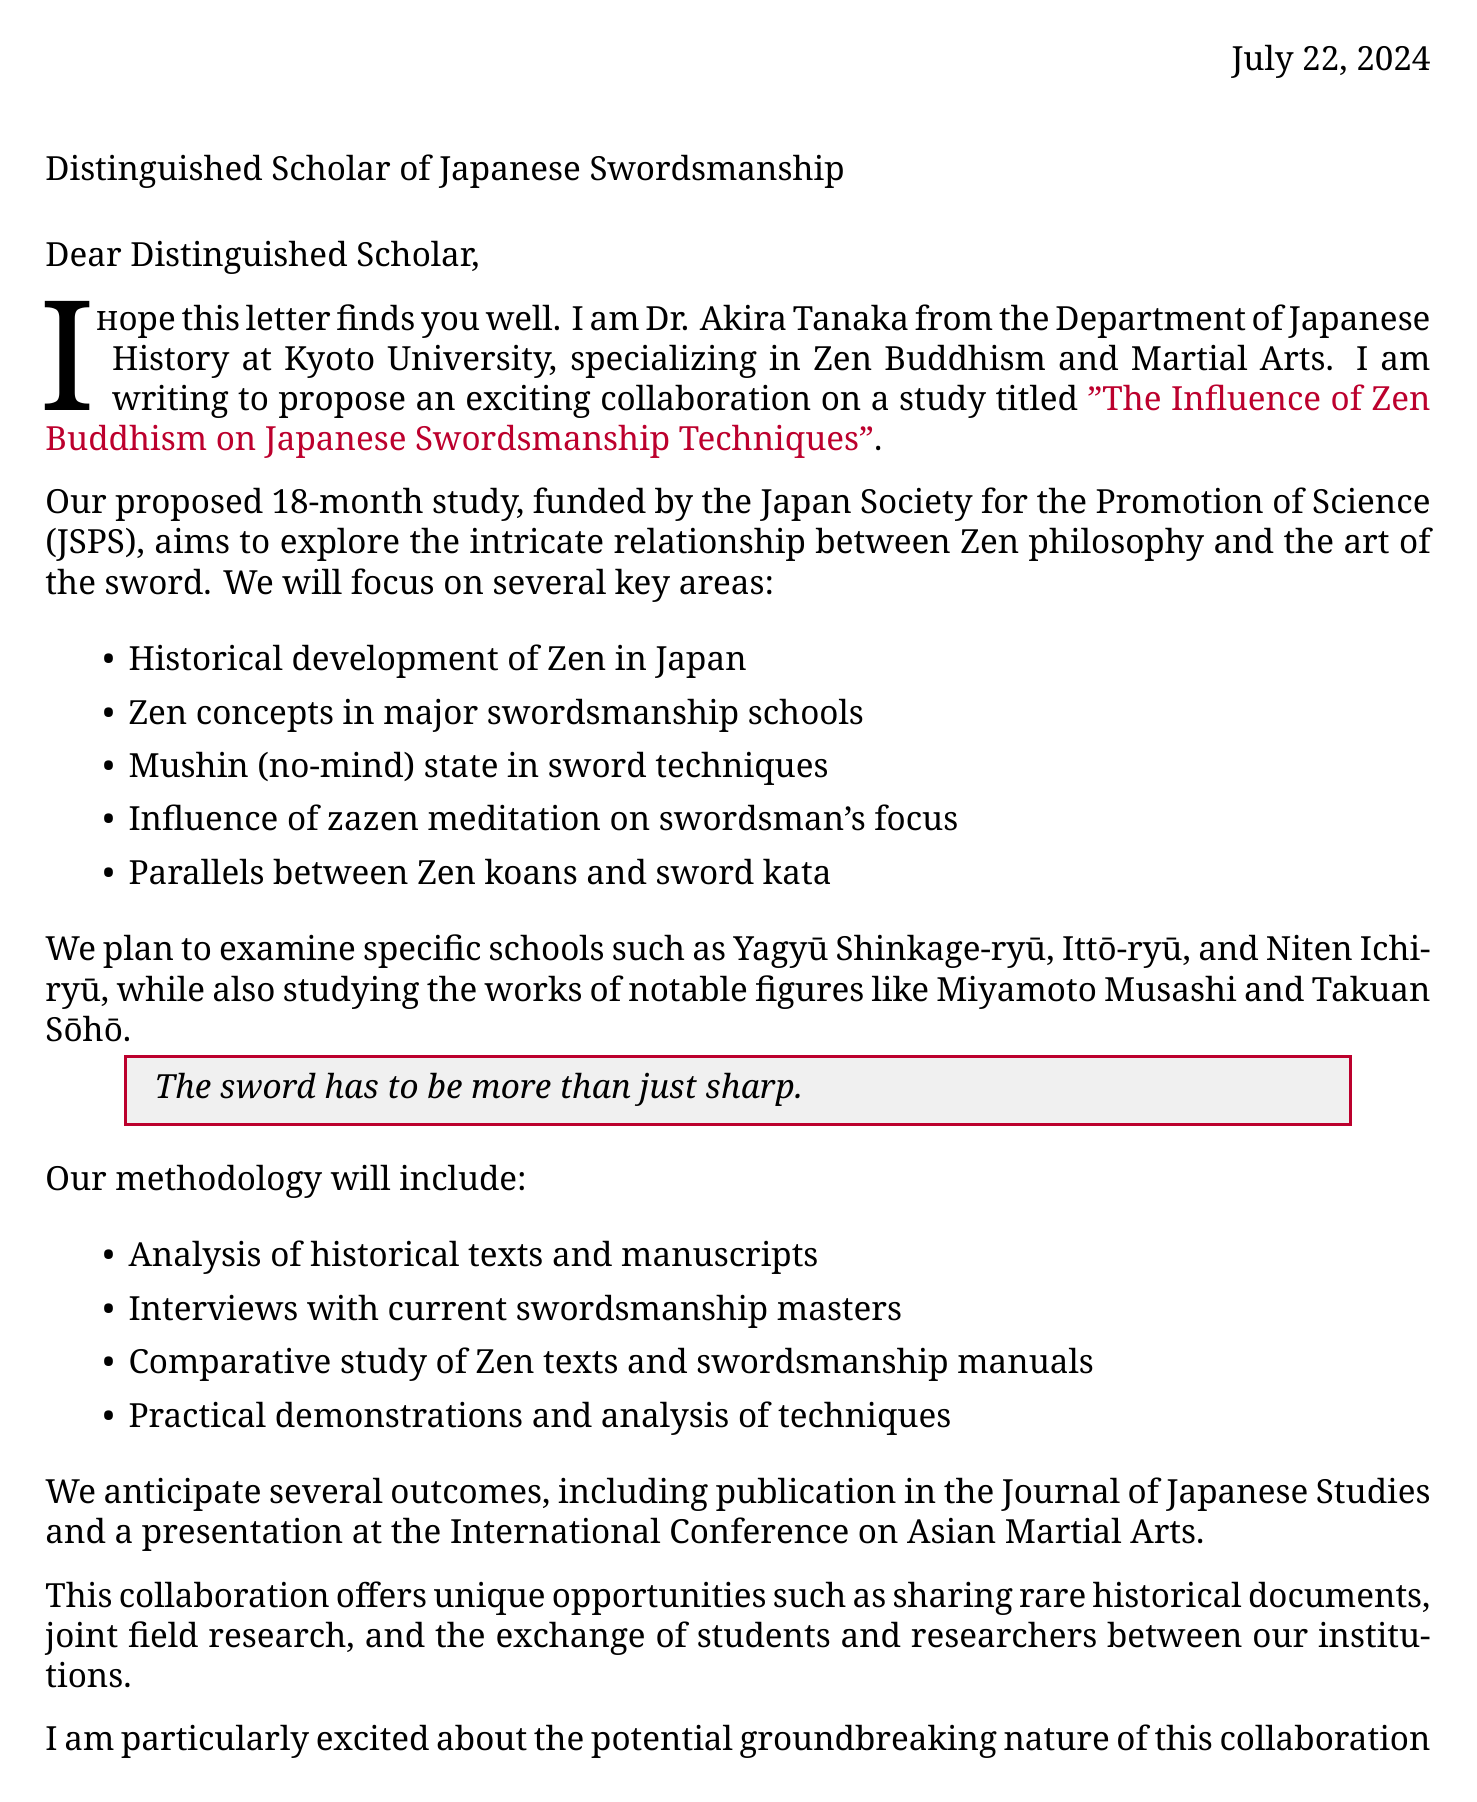What is the duration of the proposed study? The document specifies that the proposed study will last for 18 months.
Answer: 18 months Who is the sender of the letter? The sender of the letter is Dr. Akira Tanaka from Kyoto University.
Answer: Dr. Akira Tanaka Which organization is funding the study? The funding source mentioned in the document is the Japan Society for the Promotion of Science (JSPS).
Answer: Japan Society for the Promotion of Science (JSPS) What is one of the expected outcomes of the collaboration? The document lists publication in the Journal of Japanese Studies as one of the expected outcomes.
Answer: Publication in the Journal of Japanese Studies Name a historical figure mentioned in the proposed study. The letter references notable figures including Miyamoto Musashi and Takuan Sōhō.
Answer: Miyamoto Musashi What is the main focus of the proposed study? The primary focus of the proposed study is the influence of Zen Buddhism on Japanese swordsmanship techniques.
Answer: Influence of Zen Buddhism on Japanese Swordsmanship Techniques What are the specific schools to examine? The document lists Yagyū Shinkage-ryū, Ittō-ryū, and Niten Ichi-ryū as the specific schools to examine.
Answer: Yagyū Shinkage-ryū, Ittō-ryū, Niten Ichi-ryū What methodology will be used in the research? The methodology includes analysis of historical texts and manuscripts, among other methods.
Answer: Analysis of historical texts and manuscripts What is a personal note included in the letter? The closing remarks contain a personal note expressing enthusiasm about combining expertise in the field.
Answer: Looking forward to combining our expertise in this fascinating field 